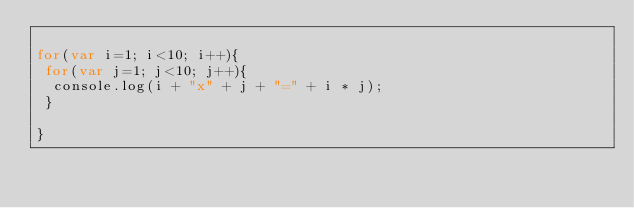Convert code to text. <code><loc_0><loc_0><loc_500><loc_500><_JavaScript_>
for(var i=1; i<10; i++){
 for(var j=1; j<10; j++){
  console.log(i + "x" + j + "=" + i * j);
 }

}</code> 